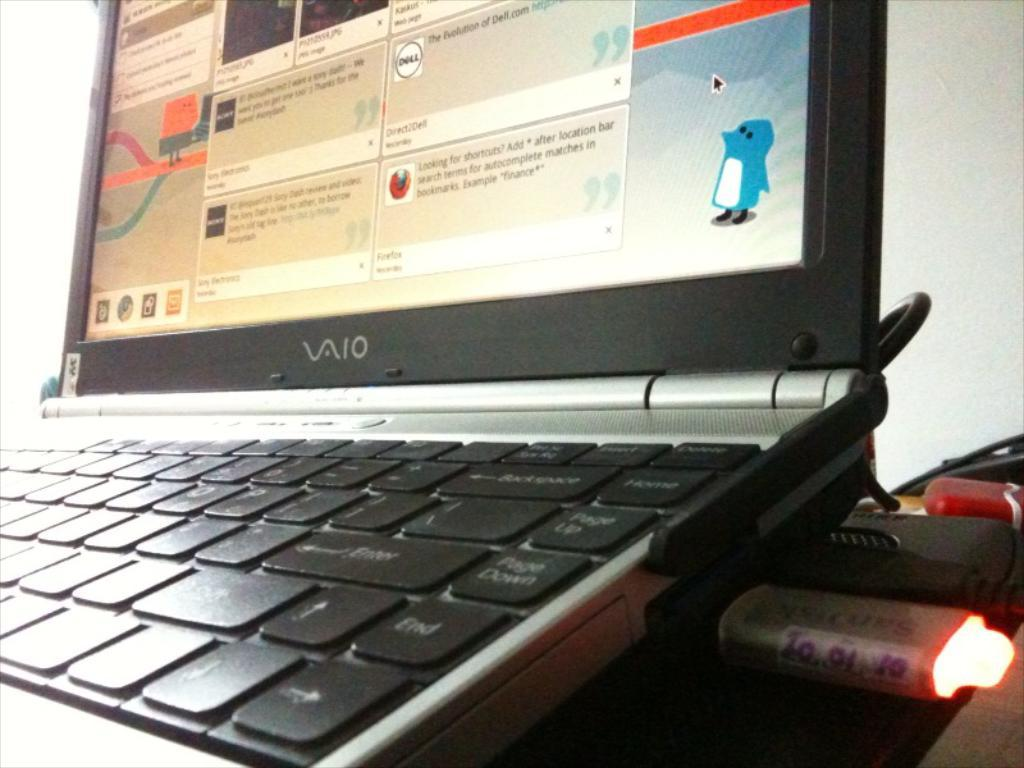<image>
Describe the image concisely. A VAIO laptop has a picture of a penguin in the lower right corner. 